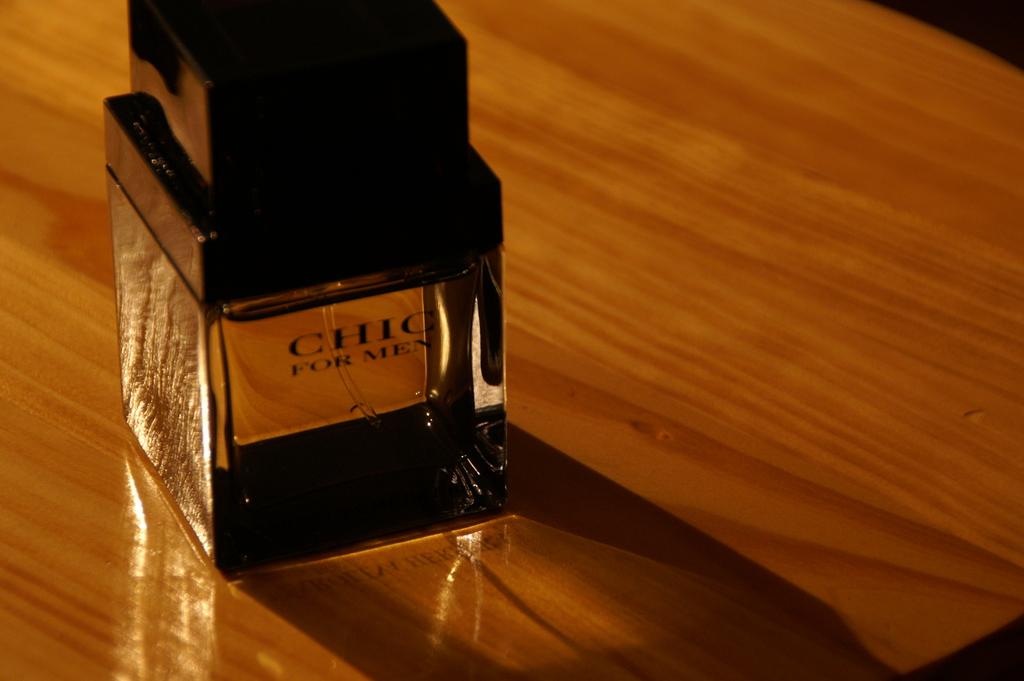For what gender is this product?
Keep it short and to the point. Men. What brand of cologne is this?
Keep it short and to the point. Chic. 